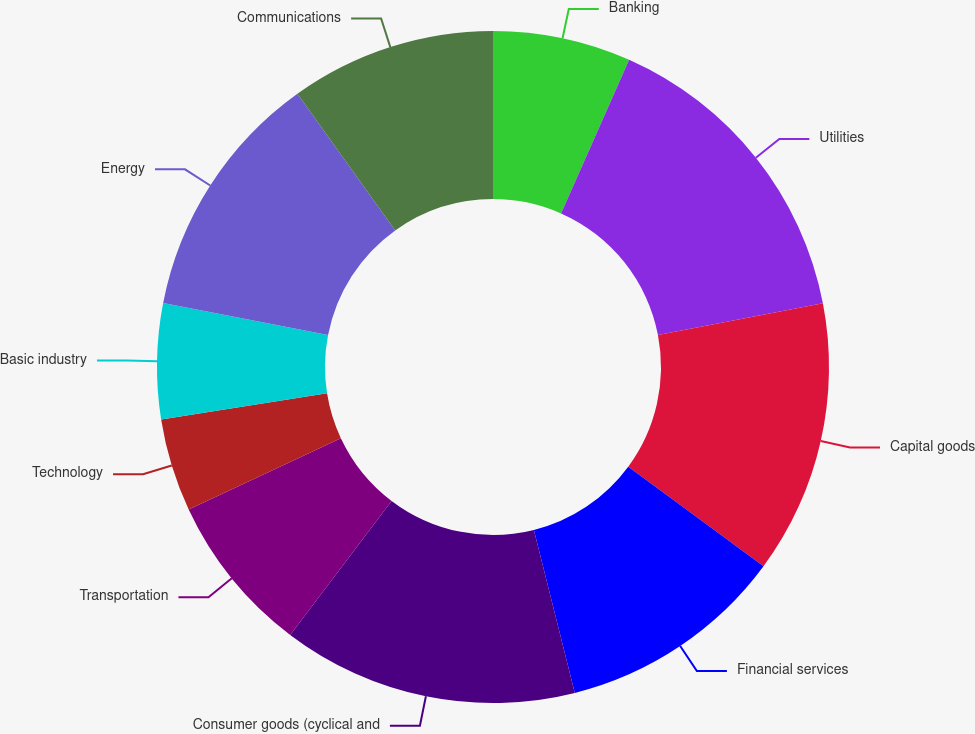Convert chart to OTSL. <chart><loc_0><loc_0><loc_500><loc_500><pie_chart><fcel>Banking<fcel>Utilities<fcel>Capital goods<fcel>Financial services<fcel>Consumer goods (cyclical and<fcel>Transportation<fcel>Technology<fcel>Basic industry<fcel>Energy<fcel>Communications<nl><fcel>6.64%<fcel>15.32%<fcel>13.15%<fcel>10.98%<fcel>14.23%<fcel>7.72%<fcel>4.47%<fcel>5.55%<fcel>12.06%<fcel>9.89%<nl></chart> 